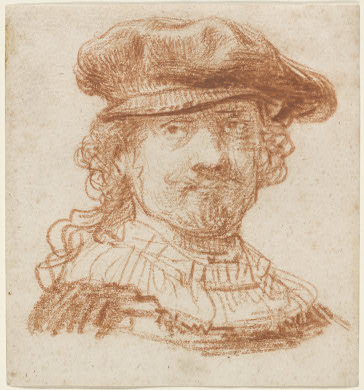What emotions does the man in the portrait seem to be expressing? The man in the portrait exudes a sense of calm and quiet confidence. His slight smile and relaxed posture suggest contemplation or satisfaction. The softness around his eyes adds a warmth to his expression, perhaps indicating a sense of wisdom or contentment. The overall demeanor is one of a dignified individual, comfortable in his own skin. 